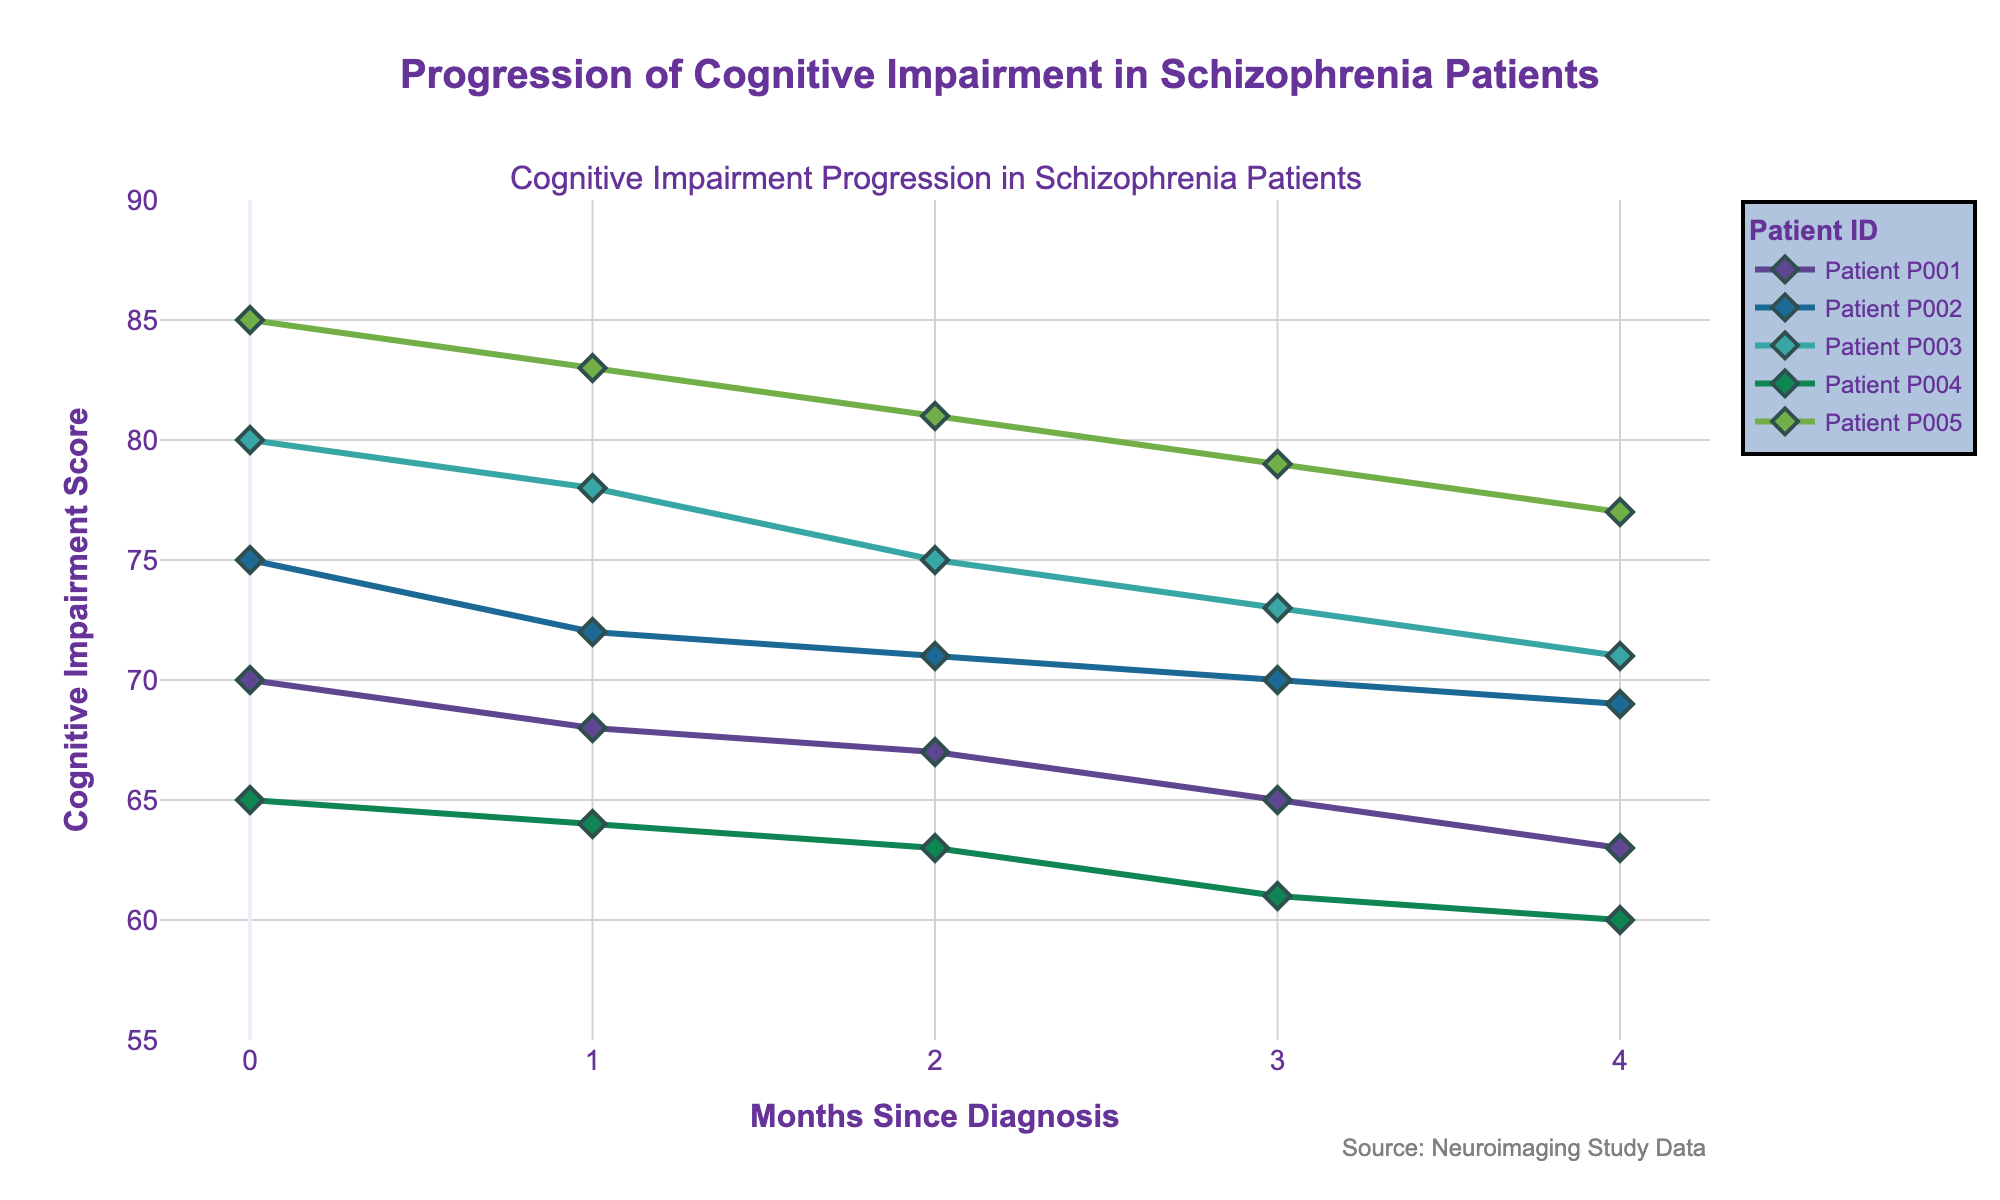Which patient has the highest cognitive impairment score at month 4? To find the highest score at month 4, check the y-values for month 4 points. Patient P005 has the highest score of 77.
Answer: Patient P005 What is the mean cognitive impairment score of Patient P002 over the 5 months? Add the cognitive impairment scores of Patient P002 (75, 72, 71, 70, 69) and divide by the number of months (5). The mean score is (75+72+71+70+69)/5 = 71.4.
Answer: 71.4 Which patient shows the greatest reduction in cognitive impairment score over time? Subtract the score at month 0 from the score at month 4 for each patient and compare. Patient P005 shows the greatest reduction, with a decline from 85 to 77 (a difference of 8).
Answer: Patient P005 Is there any patient whose cognitive impairment score remained constant? Look at the lines for each patient to see if any line is flat (no change in score). None of the patients have a flat line; scores change over time for all.
Answer: No How does the change in cognitive impairment score for Patient P004 in the first month compare to Patient P001? Calculate the score difference between month 0 and month 1 for both patients. For P004: 65 - 64 = 1. For P001: 70 - 68 = 2. Patient P001 has a greater change (larger decline).
Answer: Patient P001 shows a larger decline What is the trend in cognitive impairment scores for all patients over the 5 months? Observe the overall direction of the lines for each patient. All lines are decreasing, indicating cognitive impairment scores are dropping over time for all patients.
Answer: Decreasing trend At what month does Patient P003's cognitive impairment score first drop below 75? Check the y-values for Patient P003 at each month. The score drops below 75 at month 3 when the score is 73.
Answer: Month 3 Which patient has the least change in cognitive impairment score over 5 months? Find the patient with the smallest score difference from month 0 to month 4. Patient P002 has the least change (75 to 69), a difference of 6.
Answer: Patient P002 What was the average cognitive impairment score for all patients at month 2? Add the scores of all patients at month 2 (67, 71, 75, 63, 81) and divide by the number of patients (5). The average score is (67+71+75+63+81)/5 = 71.4.
Answer: 71.4 Which patient experienced the most consistent decline in cognitive impairment score? Look for the smoothest, most linear drop in scores from month 0 to month 4. Patient P004's scores decline in approximately equal steps each month (65, 64, 63, 61, 60).
Answer: Patient P004 